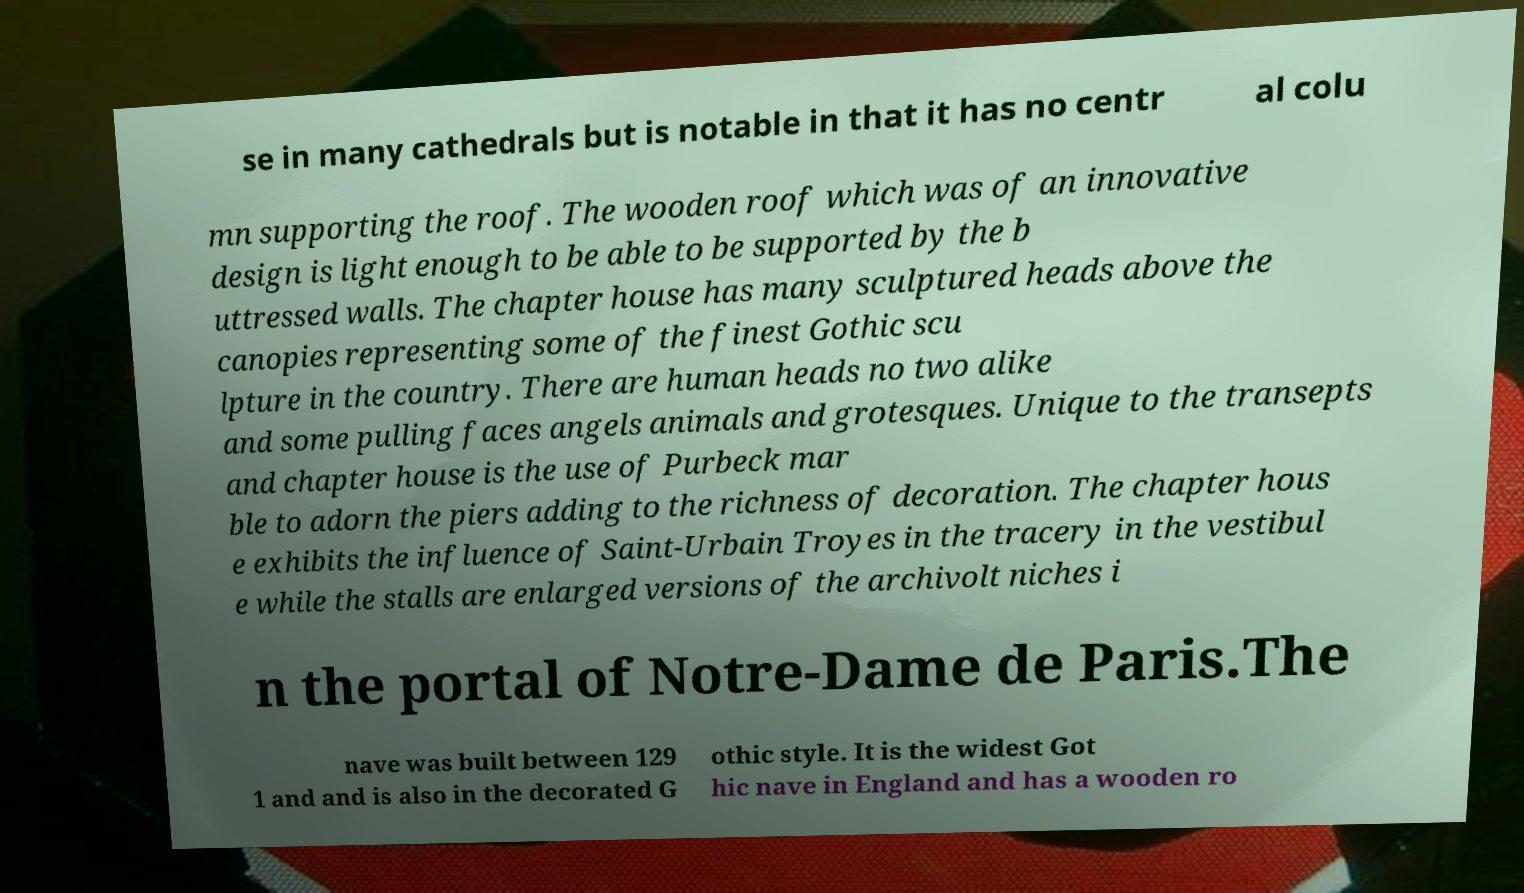Please identify and transcribe the text found in this image. se in many cathedrals but is notable in that it has no centr al colu mn supporting the roof. The wooden roof which was of an innovative design is light enough to be able to be supported by the b uttressed walls. The chapter house has many sculptured heads above the canopies representing some of the finest Gothic scu lpture in the country. There are human heads no two alike and some pulling faces angels animals and grotesques. Unique to the transepts and chapter house is the use of Purbeck mar ble to adorn the piers adding to the richness of decoration. The chapter hous e exhibits the influence of Saint-Urbain Troyes in the tracery in the vestibul e while the stalls are enlarged versions of the archivolt niches i n the portal of Notre-Dame de Paris.The nave was built between 129 1 and and is also in the decorated G othic style. It is the widest Got hic nave in England and has a wooden ro 